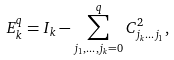Convert formula to latex. <formula><loc_0><loc_0><loc_500><loc_500>E _ { k } ^ { q } = I _ { k } - \sum _ { j _ { 1 } , \dots , j _ { k } = 0 } ^ { q } C _ { j _ { k } \dots j _ { 1 } } ^ { 2 } ,</formula> 